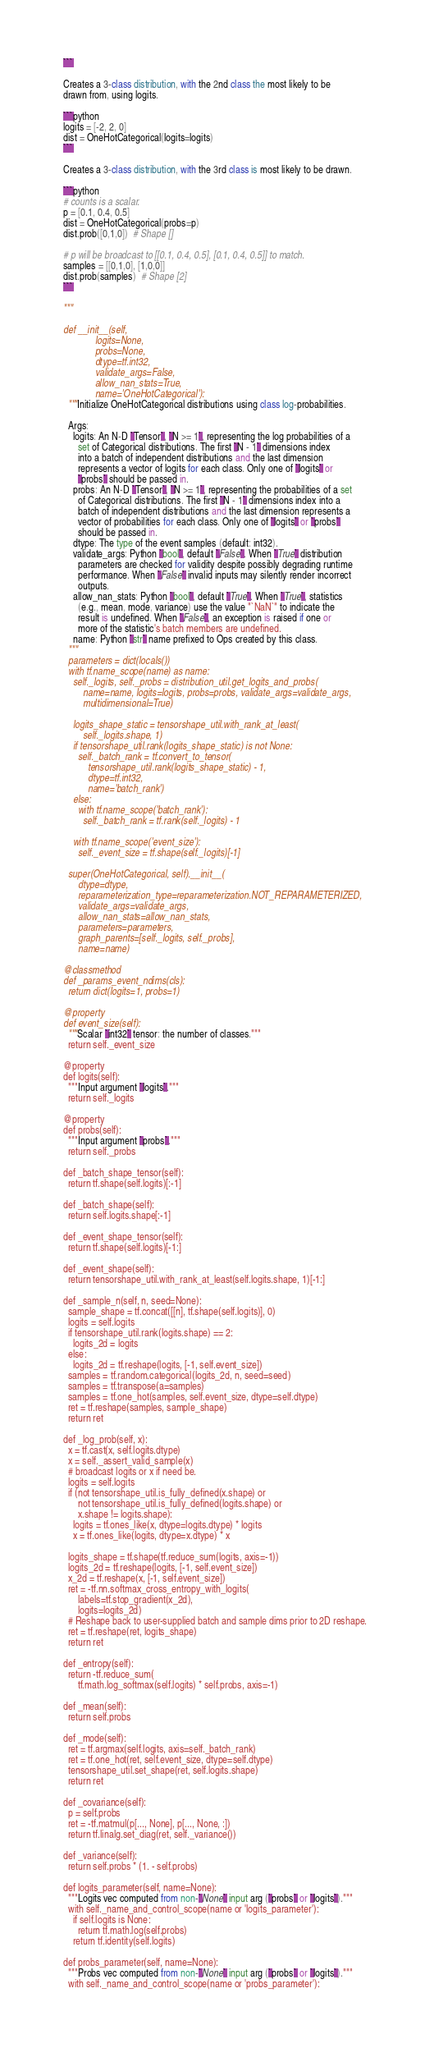<code> <loc_0><loc_0><loc_500><loc_500><_Python_>  ```

  Creates a 3-class distribution, with the 2nd class the most likely to be
  drawn from, using logits.

  ```python
  logits = [-2, 2, 0]
  dist = OneHotCategorical(logits=logits)
  ```

  Creates a 3-class distribution, with the 3rd class is most likely to be drawn.

  ```python
  # counts is a scalar.
  p = [0.1, 0.4, 0.5]
  dist = OneHotCategorical(probs=p)
  dist.prob([0,1,0])  # Shape []

  # p will be broadcast to [[0.1, 0.4, 0.5], [0.1, 0.4, 0.5]] to match.
  samples = [[0,1,0], [1,0,0]]
  dist.prob(samples)  # Shape [2]
  ```

  """

  def __init__(self,
               logits=None,
               probs=None,
               dtype=tf.int32,
               validate_args=False,
               allow_nan_stats=True,
               name='OneHotCategorical'):
    """Initialize OneHotCategorical distributions using class log-probabilities.

    Args:
      logits: An N-D `Tensor`, `N >= 1`, representing the log probabilities of a
        set of Categorical distributions. The first `N - 1` dimensions index
        into a batch of independent distributions and the last dimension
        represents a vector of logits for each class. Only one of `logits` or
        `probs` should be passed in.
      probs: An N-D `Tensor`, `N >= 1`, representing the probabilities of a set
        of Categorical distributions. The first `N - 1` dimensions index into a
        batch of independent distributions and the last dimension represents a
        vector of probabilities for each class. Only one of `logits` or `probs`
        should be passed in.
      dtype: The type of the event samples (default: int32).
      validate_args: Python `bool`, default `False`. When `True` distribution
        parameters are checked for validity despite possibly degrading runtime
        performance. When `False` invalid inputs may silently render incorrect
        outputs.
      allow_nan_stats: Python `bool`, default `True`. When `True`, statistics
        (e.g., mean, mode, variance) use the value "`NaN`" to indicate the
        result is undefined. When `False`, an exception is raised if one or
        more of the statistic's batch members are undefined.
      name: Python `str` name prefixed to Ops created by this class.
    """
    parameters = dict(locals())
    with tf.name_scope(name) as name:
      self._logits, self._probs = distribution_util.get_logits_and_probs(
          name=name, logits=logits, probs=probs, validate_args=validate_args,
          multidimensional=True)

      logits_shape_static = tensorshape_util.with_rank_at_least(
          self._logits.shape, 1)
      if tensorshape_util.rank(logits_shape_static) is not None:
        self._batch_rank = tf.convert_to_tensor(
            tensorshape_util.rank(logits_shape_static) - 1,
            dtype=tf.int32,
            name='batch_rank')
      else:
        with tf.name_scope('batch_rank'):
          self._batch_rank = tf.rank(self._logits) - 1

      with tf.name_scope('event_size'):
        self._event_size = tf.shape(self._logits)[-1]

    super(OneHotCategorical, self).__init__(
        dtype=dtype,
        reparameterization_type=reparameterization.NOT_REPARAMETERIZED,
        validate_args=validate_args,
        allow_nan_stats=allow_nan_stats,
        parameters=parameters,
        graph_parents=[self._logits, self._probs],
        name=name)

  @classmethod
  def _params_event_ndims(cls):
    return dict(logits=1, probs=1)

  @property
  def event_size(self):
    """Scalar `int32` tensor: the number of classes."""
    return self._event_size

  @property
  def logits(self):
    """Input argument `logits`."""
    return self._logits

  @property
  def probs(self):
    """Input argument `probs`."""
    return self._probs

  def _batch_shape_tensor(self):
    return tf.shape(self.logits)[:-1]

  def _batch_shape(self):
    return self.logits.shape[:-1]

  def _event_shape_tensor(self):
    return tf.shape(self.logits)[-1:]

  def _event_shape(self):
    return tensorshape_util.with_rank_at_least(self.logits.shape, 1)[-1:]

  def _sample_n(self, n, seed=None):
    sample_shape = tf.concat([[n], tf.shape(self.logits)], 0)
    logits = self.logits
    if tensorshape_util.rank(logits.shape) == 2:
      logits_2d = logits
    else:
      logits_2d = tf.reshape(logits, [-1, self.event_size])
    samples = tf.random.categorical(logits_2d, n, seed=seed)
    samples = tf.transpose(a=samples)
    samples = tf.one_hot(samples, self.event_size, dtype=self.dtype)
    ret = tf.reshape(samples, sample_shape)
    return ret

  def _log_prob(self, x):
    x = tf.cast(x, self.logits.dtype)
    x = self._assert_valid_sample(x)
    # broadcast logits or x if need be.
    logits = self.logits
    if (not tensorshape_util.is_fully_defined(x.shape) or
        not tensorshape_util.is_fully_defined(logits.shape) or
        x.shape != logits.shape):
      logits = tf.ones_like(x, dtype=logits.dtype) * logits
      x = tf.ones_like(logits, dtype=x.dtype) * x

    logits_shape = tf.shape(tf.reduce_sum(logits, axis=-1))
    logits_2d = tf.reshape(logits, [-1, self.event_size])
    x_2d = tf.reshape(x, [-1, self.event_size])
    ret = -tf.nn.softmax_cross_entropy_with_logits(
        labels=tf.stop_gradient(x_2d),
        logits=logits_2d)
    # Reshape back to user-supplied batch and sample dims prior to 2D reshape.
    ret = tf.reshape(ret, logits_shape)
    return ret

  def _entropy(self):
    return -tf.reduce_sum(
        tf.math.log_softmax(self.logits) * self.probs, axis=-1)

  def _mean(self):
    return self.probs

  def _mode(self):
    ret = tf.argmax(self.logits, axis=self._batch_rank)
    ret = tf.one_hot(ret, self.event_size, dtype=self.dtype)
    tensorshape_util.set_shape(ret, self.logits.shape)
    return ret

  def _covariance(self):
    p = self.probs
    ret = -tf.matmul(p[..., None], p[..., None, :])
    return tf.linalg.set_diag(ret, self._variance())

  def _variance(self):
    return self.probs * (1. - self.probs)

  def logits_parameter(self, name=None):
    """Logits vec computed from non-`None` input arg (`probs` or `logits`)."""
    with self._name_and_control_scope(name or 'logits_parameter'):
      if self.logits is None:
        return tf.math.log(self.probs)
      return tf.identity(self.logits)

  def probs_parameter(self, name=None):
    """Probs vec computed from non-`None` input arg (`probs` or `logits`)."""
    with self._name_and_control_scope(name or 'probs_parameter'):</code> 